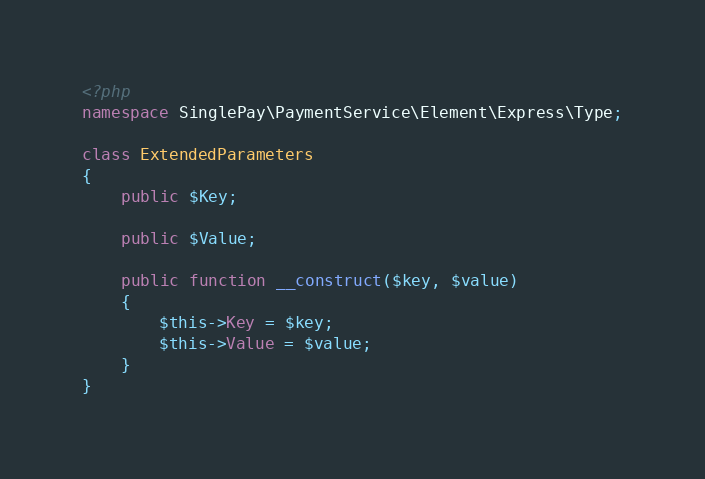<code> <loc_0><loc_0><loc_500><loc_500><_PHP_><?php
namespace SinglePay\PaymentService\Element\Express\Type;

class ExtendedParameters
{
    public $Key;

    public $Value;

    public function __construct($key, $value)
    {
        $this->Key = $key;
        $this->Value = $value;
    }
}</code> 